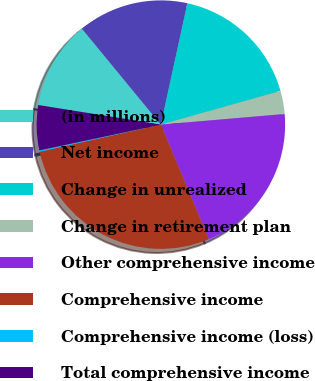Convert chart to OTSL. <chart><loc_0><loc_0><loc_500><loc_500><pie_chart><fcel>(in millions)<fcel>Net income<fcel>Change in unrealized<fcel>Change in retirement plan<fcel>Other comprehensive income<fcel>Comprehensive income<fcel>Comprehensive income (loss)<fcel>Total comprehensive income<nl><fcel>11.53%<fcel>14.37%<fcel>17.21%<fcel>3.01%<fcel>20.05%<fcel>27.81%<fcel>0.17%<fcel>5.85%<nl></chart> 